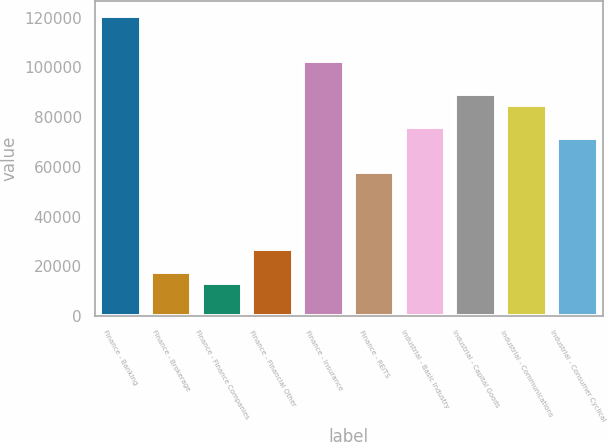<chart> <loc_0><loc_0><loc_500><loc_500><bar_chart><fcel>Finance - Banking<fcel>Finance - Brokerage<fcel>Finance - Finance Companies<fcel>Finance - Financial Other<fcel>Finance - Insurance<fcel>Finance - REITS<fcel>Industrial - Basic Industry<fcel>Industrial - Capital Goods<fcel>Industrial - Communications<fcel>Industrial - Consumer Cyclical<nl><fcel>120654<fcel>17904.3<fcel>13436.9<fcel>26839.1<fcel>102785<fcel>58110.9<fcel>75980.5<fcel>89382.7<fcel>84915.3<fcel>71513.1<nl></chart> 